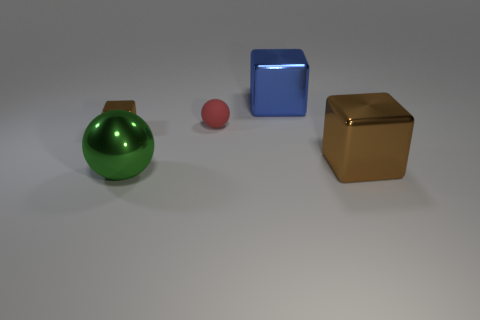Is the number of tiny things that are behind the tiny shiny block less than the number of large balls on the right side of the tiny ball?
Make the answer very short. No. The green thing that is the same material as the big brown block is what shape?
Make the answer very short. Sphere. How big is the brown block right of the ball in front of the tiny object that is to the left of the tiny red matte ball?
Your response must be concise. Large. Is the number of small gray things greater than the number of shiny spheres?
Ensure brevity in your answer.  No. Is the color of the block that is to the left of the metal sphere the same as the large thing right of the blue shiny object?
Provide a succinct answer. Yes. Is the material of the sphere that is to the left of the small red matte ball the same as the large cube that is in front of the big blue metallic thing?
Offer a terse response. Yes. How many spheres are the same size as the blue metal cube?
Your answer should be compact. 1. Are there fewer large objects than big blue metal objects?
Give a very brief answer. No. There is a brown metallic object that is behind the big metal block that is in front of the small metal cube; what shape is it?
Your answer should be compact. Cube. What is the shape of the green shiny object that is the same size as the blue metallic object?
Your response must be concise. Sphere. 